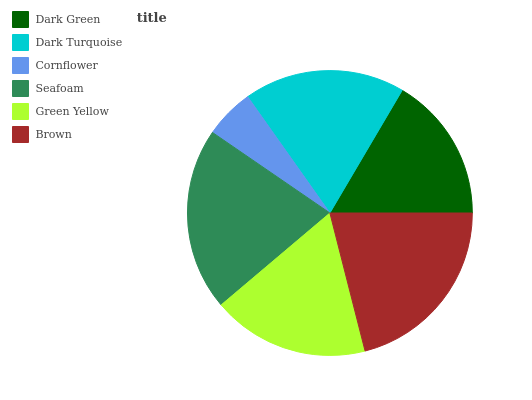Is Cornflower the minimum?
Answer yes or no. Yes. Is Brown the maximum?
Answer yes or no. Yes. Is Dark Turquoise the minimum?
Answer yes or no. No. Is Dark Turquoise the maximum?
Answer yes or no. No. Is Dark Turquoise greater than Dark Green?
Answer yes or no. Yes. Is Dark Green less than Dark Turquoise?
Answer yes or no. Yes. Is Dark Green greater than Dark Turquoise?
Answer yes or no. No. Is Dark Turquoise less than Dark Green?
Answer yes or no. No. Is Dark Turquoise the high median?
Answer yes or no. Yes. Is Green Yellow the low median?
Answer yes or no. Yes. Is Green Yellow the high median?
Answer yes or no. No. Is Dark Turquoise the low median?
Answer yes or no. No. 